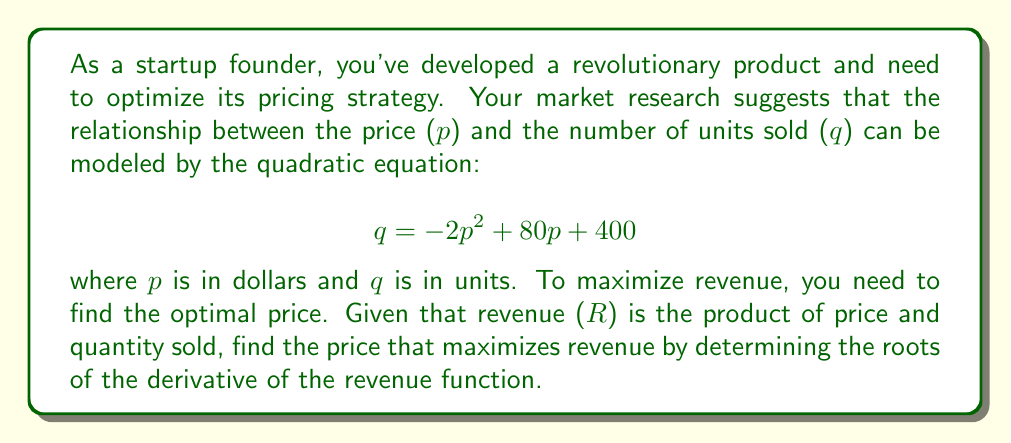Help me with this question. Let's approach this step-by-step:

1) First, we need to express revenue (R) as a function of price (p):
   $$ R = p \cdot q = p(-2p^2 + 80p + 400) = -2p^3 + 80p^2 + 400p $$

2) To find the maximum revenue, we need to find where the derivative of R with respect to p is zero:
   $$ \frac{dR}{dp} = -6p^2 + 160p + 400 $$

3) Setting this equal to zero:
   $$ -6p^2 + 160p + 400 = 0 $$

4) This is a quadratic equation. We can solve it using the quadratic formula:
   $$ p = \frac{-b \pm \sqrt{b^2 - 4ac}}{2a} $$
   where $a = -6$, $b = 160$, and $c = 400$

5) Substituting these values:
   $$ p = \frac{-160 \pm \sqrt{160^2 - 4(-6)(400)}}{2(-6)} $$
   $$ = \frac{-160 \pm \sqrt{25600 + 9600}}{-12} $$
   $$ = \frac{-160 \pm \sqrt{35200}}{-12} $$
   $$ = \frac{-160 \pm 187.62}{-12} $$

6) This gives us two solutions:
   $$ p_1 = \frac{-160 + 187.62}{-12} \approx 2.30 $$
   $$ p_2 = \frac{-160 - 187.62}{-12} \approx 28.97 $$

7) The second derivative of R is:
   $$ \frac{d^2R}{dp^2} = -12p + 160 $$

8) Evaluating this at $p_1 = 2.30$ gives a positive value, while at $p_2 = 28.97$ it gives a negative value. Therefore, $p_2$ is the maximum.
Answer: The optimal price to maximize revenue is approximately $28.97. 